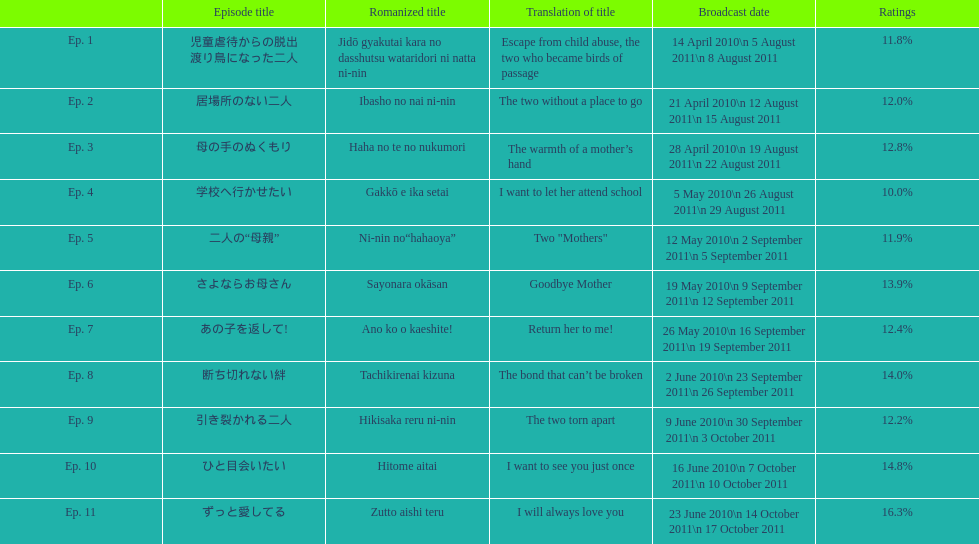What episode was called "i want to let her attend school"? Ep. 4. 